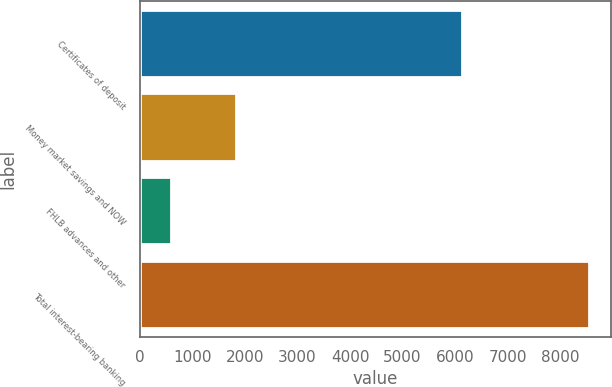Convert chart to OTSL. <chart><loc_0><loc_0><loc_500><loc_500><bar_chart><fcel>Certificates of deposit<fcel>Money market savings and NOW<fcel>FHLB advances and other<fcel>Total interest-bearing banking<nl><fcel>6126<fcel>1833<fcel>588<fcel>8547<nl></chart> 